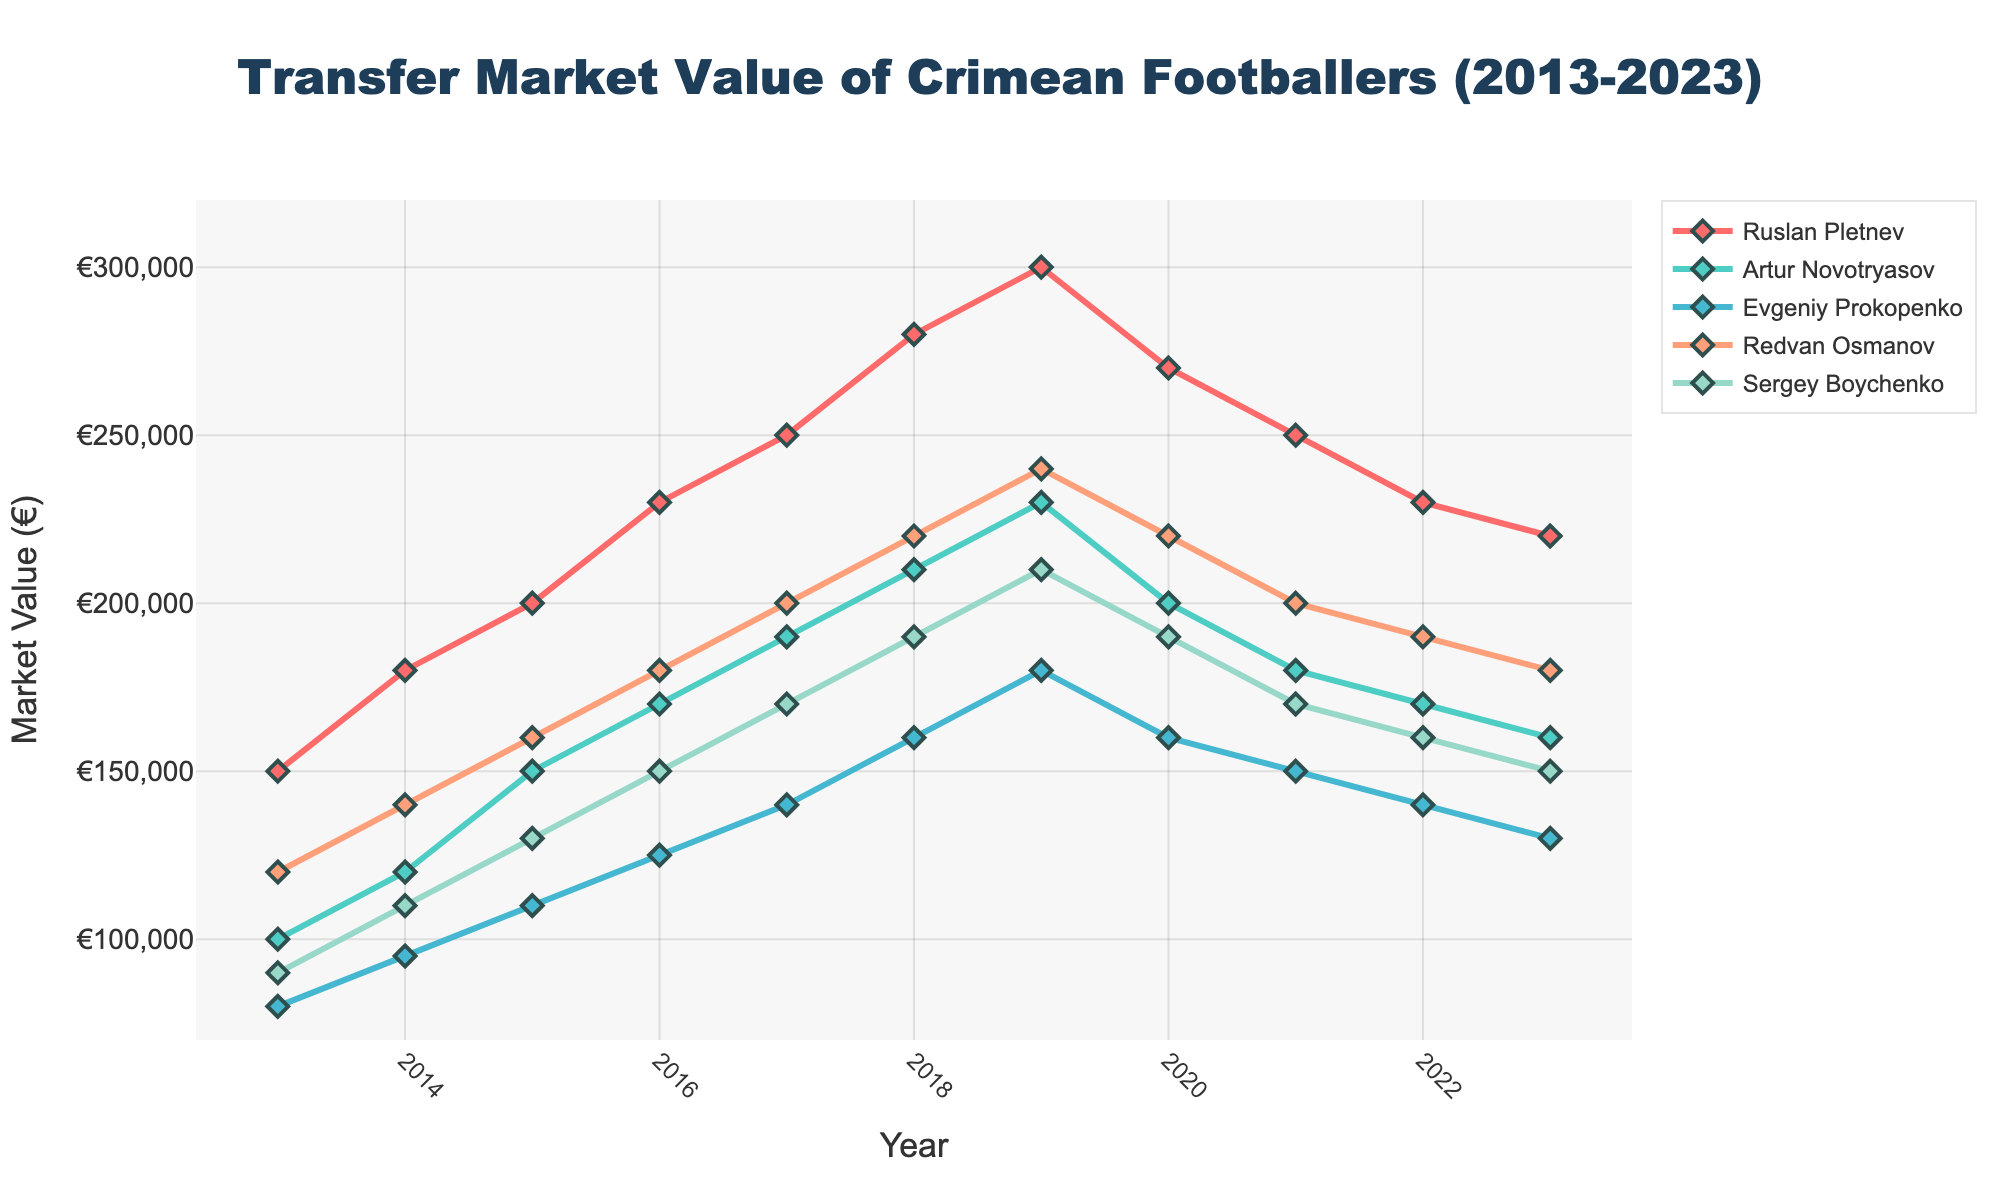Which footballer had the highest market value in 2016? To find the footballer with the highest market value in 2016, examine the y-axis values for each player's line at the 2016 x-axis point. Ruslan Pletnev had the highest value with €230,000.
Answer: Ruslan Pletnev How did Artur Novotryasov's market value change from 2019 to 2020? Look at Artur Novotryasov's y-axis values in 2019 and 2020. His value decreased from €230,000 to €200,000, which is a difference of €30,000.
Answer: Decreased by €30,000 Which two years did Redvan Osmanov achieve his peak market value? Check the y-axis values for Redvan Osmanov's line and identify the highest points. His peak values are in 2019 and 2018, both reaching €240,000.
Answer: 2018 and 2019 Among Sergey Boychenko and Evgeniy Prokopenko, who had a higher market value in 2015? Compare the y-axis values of Sergey Boychenko and Evgeniy Prokopenko in the year 2015. Sergey Boychenko's value was €130,000, which is higher than Evgeniy Prokopenko's €110,000.
Answer: Sergey Boychenko What is the average market value of Ruslan Pletnev over the entire decade? Sum up Ruslan Pletnev's market values from 2013 to 2023 and then divide by the number of years (11). The values are [150000, 180000, 200000, 230000, 250000, 280000, 300000, 270000, 250000, 230000, 220000], summing to €2560000. Average: €2560000/11 ≈ €232727.
Answer: €232727 In which year did all five footballers see a decrease in their market value compared to the previous year? Scan through the lines and check for a year where each footballer's market value is lower than the year before. In 2020, each footballer’s market value decreased compared to 2019.
Answer: 2020 Which footballer had the least fluctuation in market value from 2013 to 2023? Observe the ymax and ymin values for each player and calculate the difference (fluctuation). Compare these differences. Sergey Boychenko had a range from €90,000 to €210,000, thus fluctuation of €120,000, which is the least fluctuation among all players.
Answer: Sergey Boychenko Whose market value recovered the most from 2021 to 2023? Look at how market values changed from 2021 to 2023 for each player and identify the one with the greatest increase. None of the players had a net increase from 2021 to 2023; thus, no player showed a recovery.
Answer: No recovery 